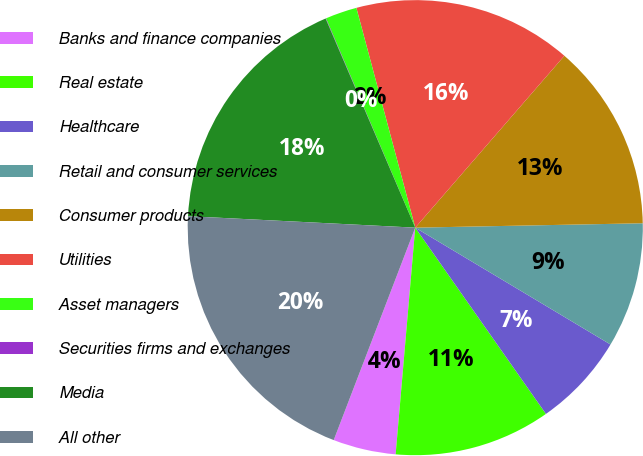Convert chart to OTSL. <chart><loc_0><loc_0><loc_500><loc_500><pie_chart><fcel>Banks and finance companies<fcel>Real estate<fcel>Healthcare<fcel>Retail and consumer services<fcel>Consumer products<fcel>Utilities<fcel>Asset managers<fcel>Securities firms and exchanges<fcel>Media<fcel>All other<nl><fcel>4.46%<fcel>11.11%<fcel>6.68%<fcel>8.89%<fcel>13.32%<fcel>15.54%<fcel>2.25%<fcel>0.03%<fcel>17.75%<fcel>19.97%<nl></chart> 